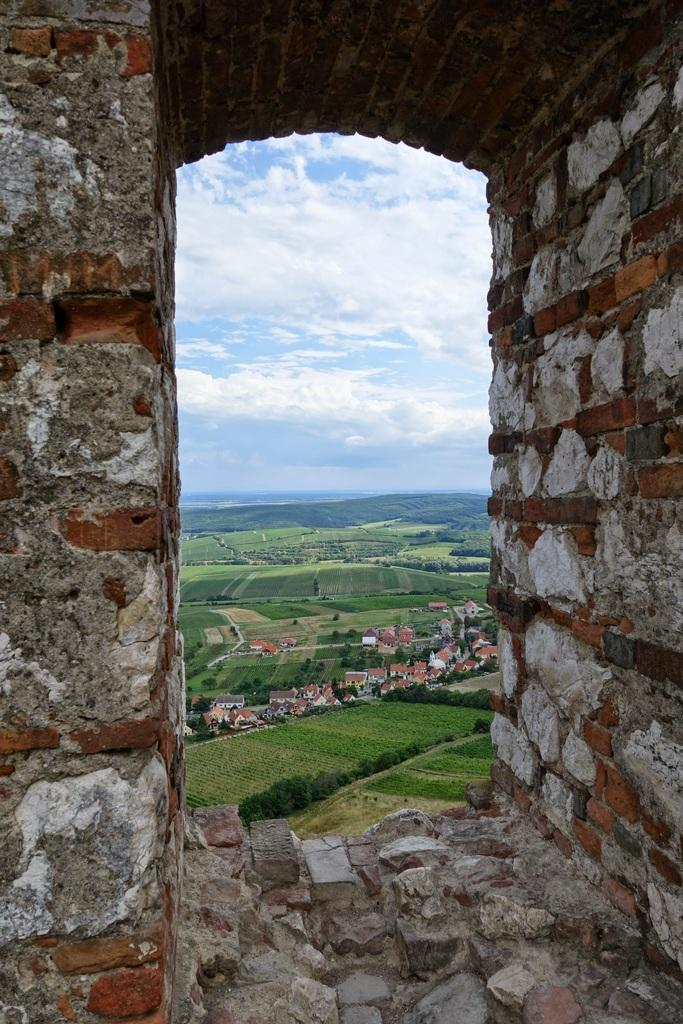What type of structure can be seen in the image? There is a wall in the image. What other structures are visible in the image? There are buildings in the image. What type of vegetation is present in the image? There are trees and grass in the image. What can be seen in the background of the image? The sky is visible in the background of the image, and clouds are present in the sky. What type of horn can be heard coming from the church in the image? There is no church or horn present in the image, so it's not possible to determine what, if any, horn might be heard. 